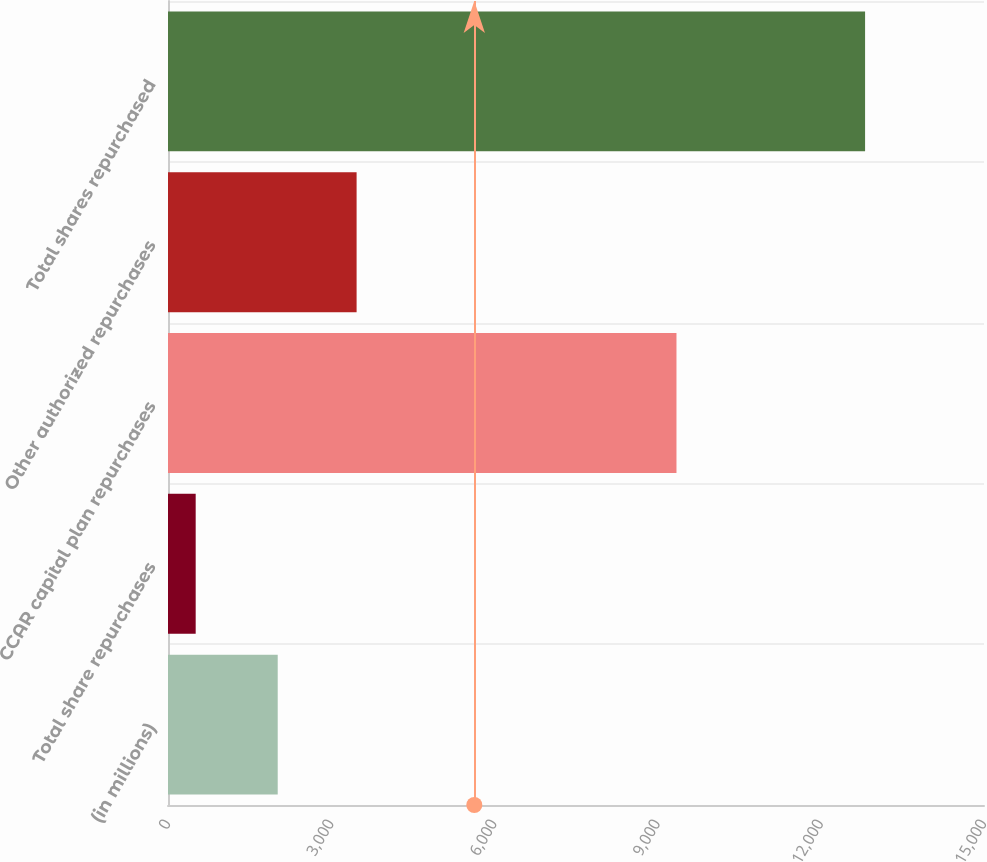Convert chart. <chart><loc_0><loc_0><loc_500><loc_500><bar_chart><fcel>(in millions)<fcel>Total share repurchases<fcel>CCAR capital plan repurchases<fcel>Other authorized repurchases<fcel>Total shares repurchased<nl><fcel>2017<fcel>509<fcel>9347<fcel>3467<fcel>12814<nl></chart> 